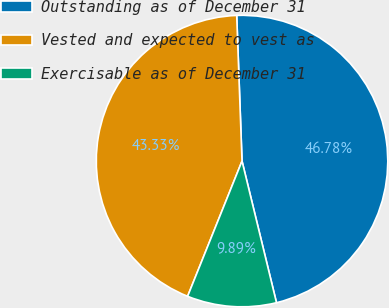<chart> <loc_0><loc_0><loc_500><loc_500><pie_chart><fcel>Outstanding as of December 31<fcel>Vested and expected to vest as<fcel>Exercisable as of December 31<nl><fcel>46.78%<fcel>43.33%<fcel>9.89%<nl></chart> 